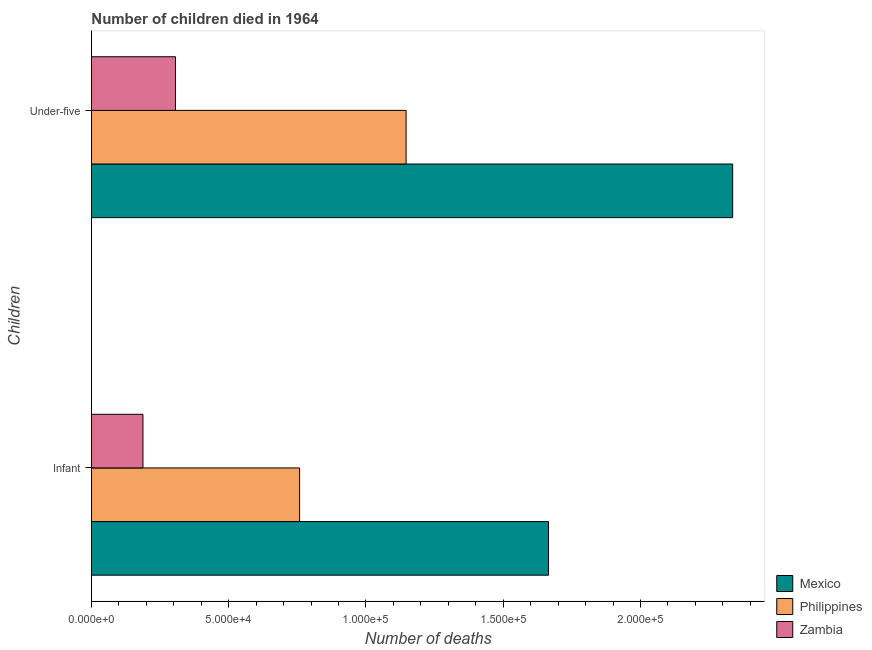Are the number of bars per tick equal to the number of legend labels?
Give a very brief answer. Yes. How many bars are there on the 1st tick from the bottom?
Offer a terse response. 3. What is the label of the 1st group of bars from the top?
Provide a succinct answer. Under-five. What is the number of under-five deaths in Zambia?
Your answer should be very brief. 3.06e+04. Across all countries, what is the maximum number of infant deaths?
Keep it short and to the point. 1.67e+05. Across all countries, what is the minimum number of under-five deaths?
Your answer should be compact. 3.06e+04. In which country was the number of under-five deaths minimum?
Keep it short and to the point. Zambia. What is the total number of under-five deaths in the graph?
Your response must be concise. 3.79e+05. What is the difference between the number of infant deaths in Zambia and that in Philippines?
Your response must be concise. -5.71e+04. What is the difference between the number of infant deaths in Philippines and the number of under-five deaths in Mexico?
Provide a short and direct response. -1.58e+05. What is the average number of infant deaths per country?
Offer a terse response. 8.70e+04. What is the difference between the number of under-five deaths and number of infant deaths in Zambia?
Your answer should be compact. 1.19e+04. In how many countries, is the number of under-five deaths greater than 190000 ?
Make the answer very short. 1. What is the ratio of the number of infant deaths in Mexico to that in Zambia?
Provide a succinct answer. 8.87. In how many countries, is the number of infant deaths greater than the average number of infant deaths taken over all countries?
Offer a terse response. 1. What does the 2nd bar from the top in Infant represents?
Provide a short and direct response. Philippines. What does the 3rd bar from the bottom in Under-five represents?
Offer a terse response. Zambia. How many bars are there?
Make the answer very short. 6. Are all the bars in the graph horizontal?
Provide a succinct answer. Yes. How many countries are there in the graph?
Your answer should be very brief. 3. How are the legend labels stacked?
Give a very brief answer. Vertical. What is the title of the graph?
Make the answer very short. Number of children died in 1964. Does "Sweden" appear as one of the legend labels in the graph?
Make the answer very short. No. What is the label or title of the X-axis?
Offer a terse response. Number of deaths. What is the label or title of the Y-axis?
Offer a very short reply. Children. What is the Number of deaths of Mexico in Infant?
Your answer should be compact. 1.67e+05. What is the Number of deaths of Philippines in Infant?
Your answer should be very brief. 7.58e+04. What is the Number of deaths of Zambia in Infant?
Make the answer very short. 1.88e+04. What is the Number of deaths in Mexico in Under-five?
Your answer should be very brief. 2.34e+05. What is the Number of deaths in Philippines in Under-five?
Give a very brief answer. 1.15e+05. What is the Number of deaths in Zambia in Under-five?
Make the answer very short. 3.06e+04. Across all Children, what is the maximum Number of deaths of Mexico?
Offer a terse response. 2.34e+05. Across all Children, what is the maximum Number of deaths in Philippines?
Give a very brief answer. 1.15e+05. Across all Children, what is the maximum Number of deaths in Zambia?
Offer a terse response. 3.06e+04. Across all Children, what is the minimum Number of deaths of Mexico?
Give a very brief answer. 1.67e+05. Across all Children, what is the minimum Number of deaths of Philippines?
Keep it short and to the point. 7.58e+04. Across all Children, what is the minimum Number of deaths in Zambia?
Your answer should be compact. 1.88e+04. What is the total Number of deaths of Mexico in the graph?
Keep it short and to the point. 4.00e+05. What is the total Number of deaths in Philippines in the graph?
Your answer should be very brief. 1.90e+05. What is the total Number of deaths in Zambia in the graph?
Give a very brief answer. 4.94e+04. What is the difference between the Number of deaths of Mexico in Infant and that in Under-five?
Your response must be concise. -6.71e+04. What is the difference between the Number of deaths of Philippines in Infant and that in Under-five?
Provide a succinct answer. -3.88e+04. What is the difference between the Number of deaths in Zambia in Infant and that in Under-five?
Provide a succinct answer. -1.19e+04. What is the difference between the Number of deaths in Mexico in Infant and the Number of deaths in Philippines in Under-five?
Provide a short and direct response. 5.19e+04. What is the difference between the Number of deaths of Mexico in Infant and the Number of deaths of Zambia in Under-five?
Offer a very short reply. 1.36e+05. What is the difference between the Number of deaths in Philippines in Infant and the Number of deaths in Zambia in Under-five?
Ensure brevity in your answer.  4.52e+04. What is the average Number of deaths of Mexico per Children?
Ensure brevity in your answer.  2.00e+05. What is the average Number of deaths of Philippines per Children?
Your answer should be compact. 9.52e+04. What is the average Number of deaths of Zambia per Children?
Ensure brevity in your answer.  2.47e+04. What is the difference between the Number of deaths of Mexico and Number of deaths of Philippines in Infant?
Keep it short and to the point. 9.07e+04. What is the difference between the Number of deaths of Mexico and Number of deaths of Zambia in Infant?
Your answer should be very brief. 1.48e+05. What is the difference between the Number of deaths in Philippines and Number of deaths in Zambia in Infant?
Offer a very short reply. 5.71e+04. What is the difference between the Number of deaths of Mexico and Number of deaths of Philippines in Under-five?
Make the answer very short. 1.19e+05. What is the difference between the Number of deaths in Mexico and Number of deaths in Zambia in Under-five?
Offer a terse response. 2.03e+05. What is the difference between the Number of deaths in Philippines and Number of deaths in Zambia in Under-five?
Provide a short and direct response. 8.40e+04. What is the ratio of the Number of deaths in Mexico in Infant to that in Under-five?
Your answer should be very brief. 0.71. What is the ratio of the Number of deaths of Philippines in Infant to that in Under-five?
Give a very brief answer. 0.66. What is the ratio of the Number of deaths in Zambia in Infant to that in Under-five?
Offer a terse response. 0.61. What is the difference between the highest and the second highest Number of deaths in Mexico?
Offer a very short reply. 6.71e+04. What is the difference between the highest and the second highest Number of deaths in Philippines?
Keep it short and to the point. 3.88e+04. What is the difference between the highest and the second highest Number of deaths of Zambia?
Make the answer very short. 1.19e+04. What is the difference between the highest and the lowest Number of deaths in Mexico?
Make the answer very short. 6.71e+04. What is the difference between the highest and the lowest Number of deaths in Philippines?
Offer a terse response. 3.88e+04. What is the difference between the highest and the lowest Number of deaths of Zambia?
Your answer should be compact. 1.19e+04. 